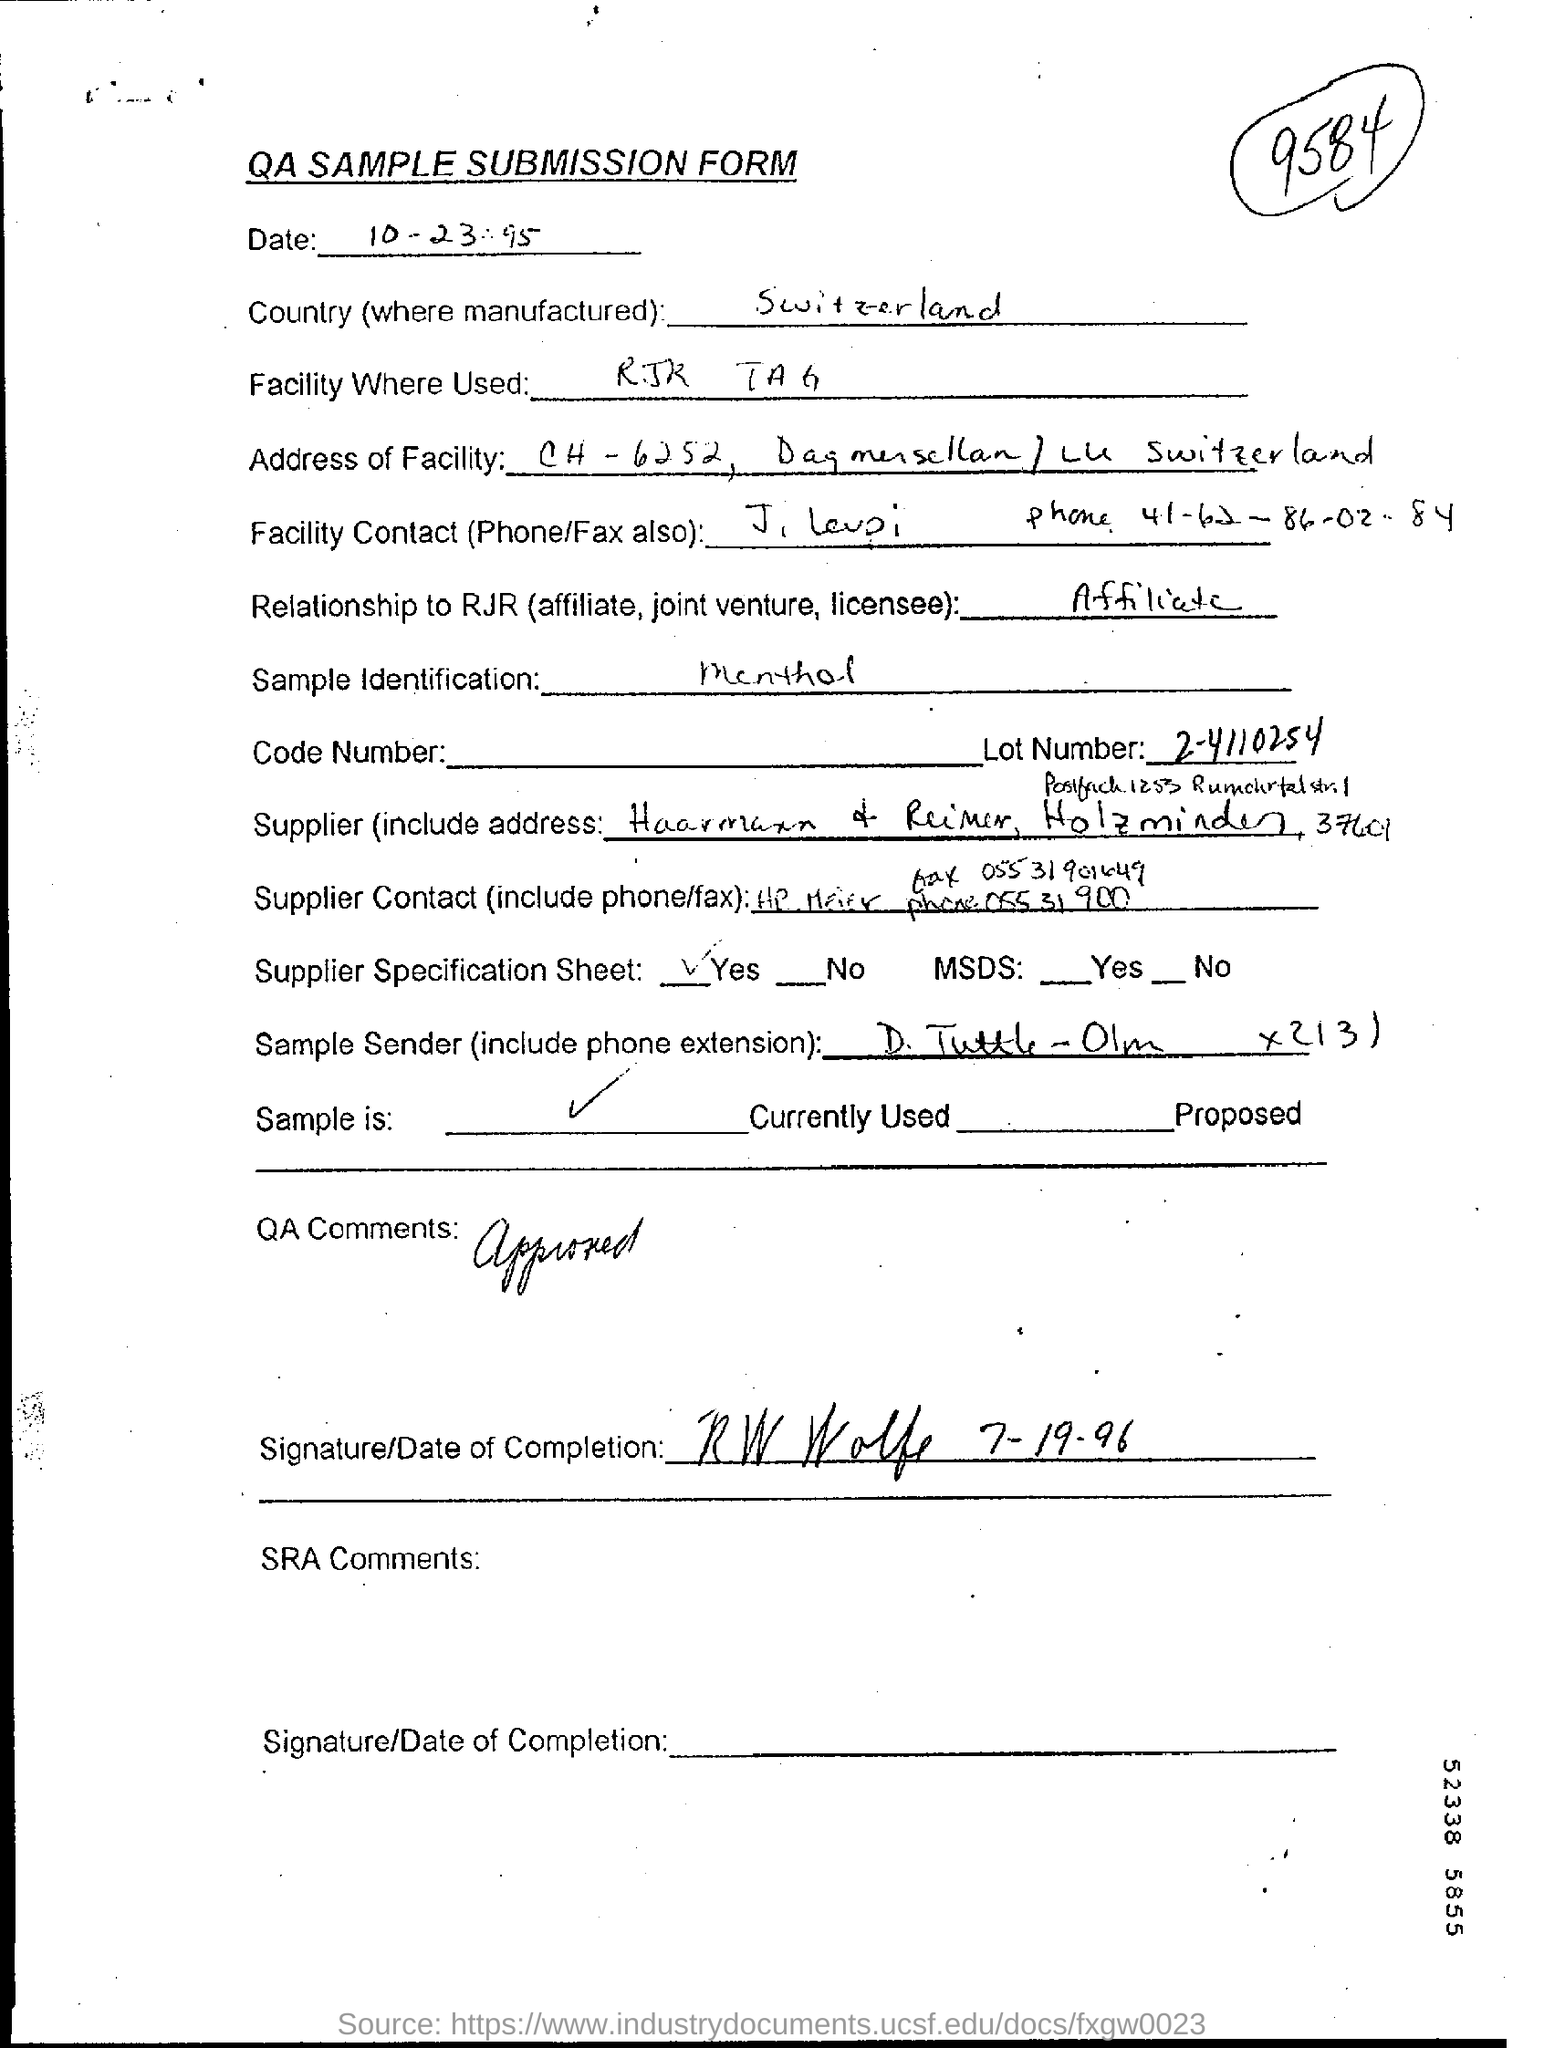What is the document title?
Give a very brief answer. QA Sample Submission Form. Which country is mentioned?
Provide a succinct answer. Switzerland. Which facility is used?
Keep it short and to the point. RJR TAG. What is the relationship to RJR?
Offer a very short reply. Affiliate. What is the Lot Number?
Offer a terse response. 2-4110254. What is the sample identification specified?
Ensure brevity in your answer.  Menthol. What is given in the QA comments?
Make the answer very short. Approved. 